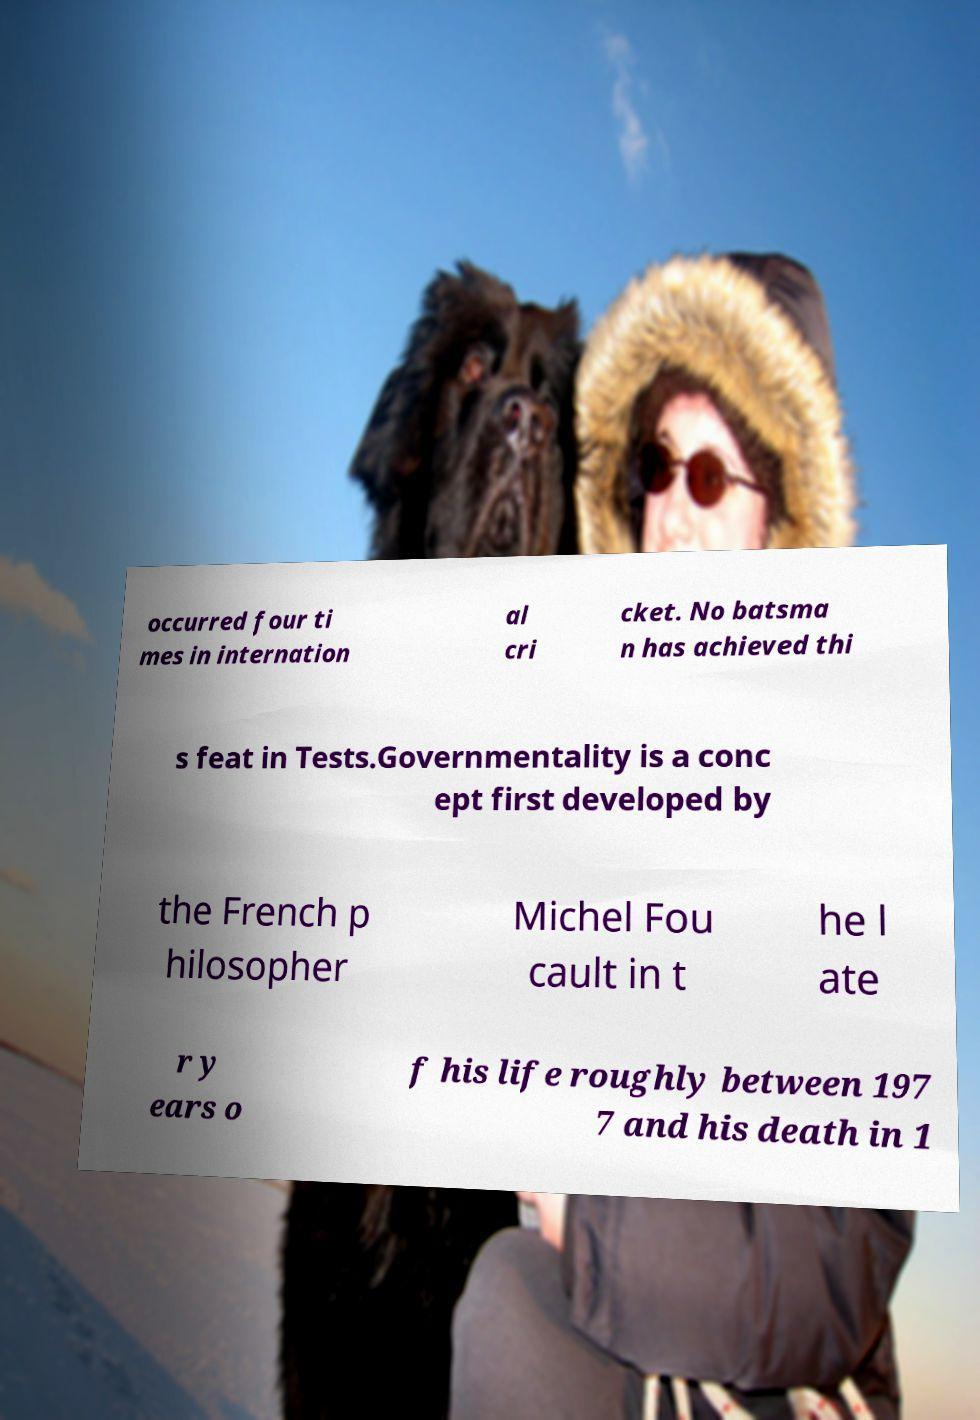Please identify and transcribe the text found in this image. occurred four ti mes in internation al cri cket. No batsma n has achieved thi s feat in Tests.Governmentality is a conc ept first developed by the French p hilosopher Michel Fou cault in t he l ate r y ears o f his life roughly between 197 7 and his death in 1 